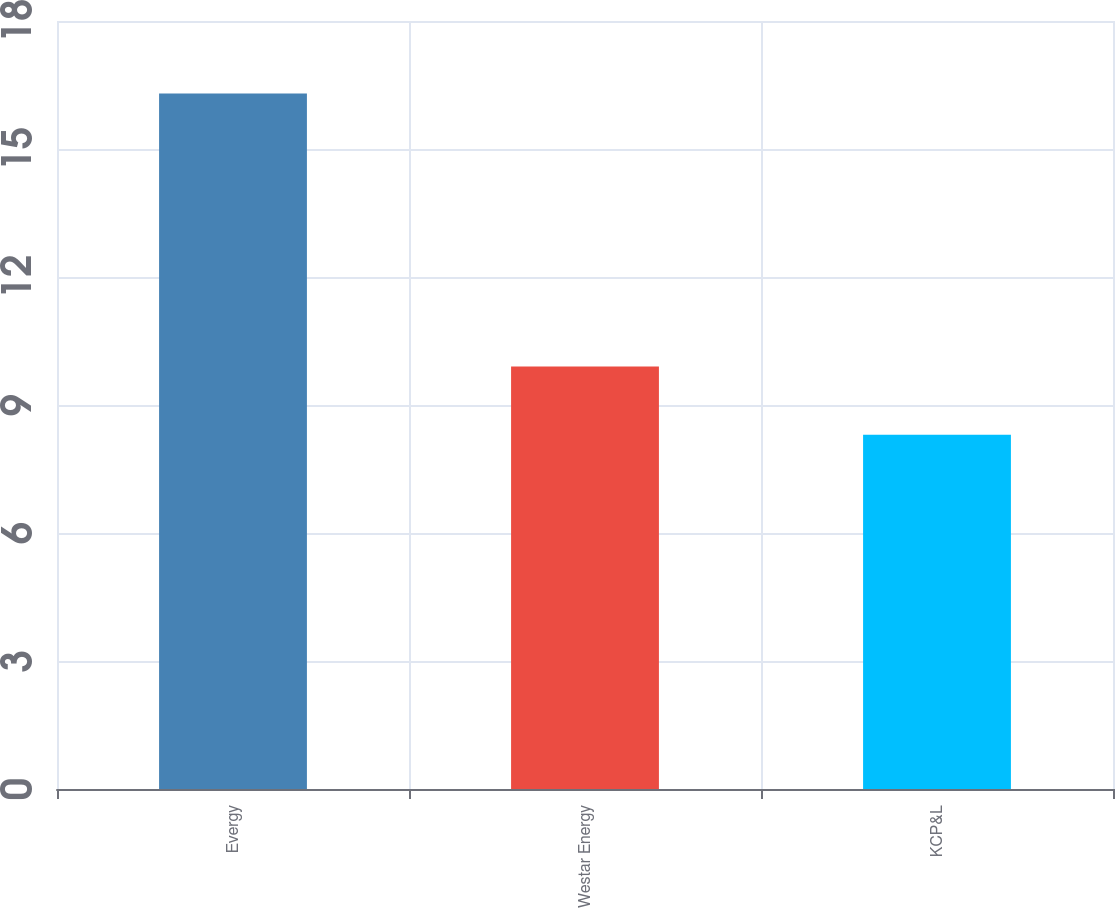Convert chart to OTSL. <chart><loc_0><loc_0><loc_500><loc_500><bar_chart><fcel>Evergy<fcel>Westar Energy<fcel>KCP&L<nl><fcel>16.3<fcel>9.9<fcel>8.3<nl></chart> 